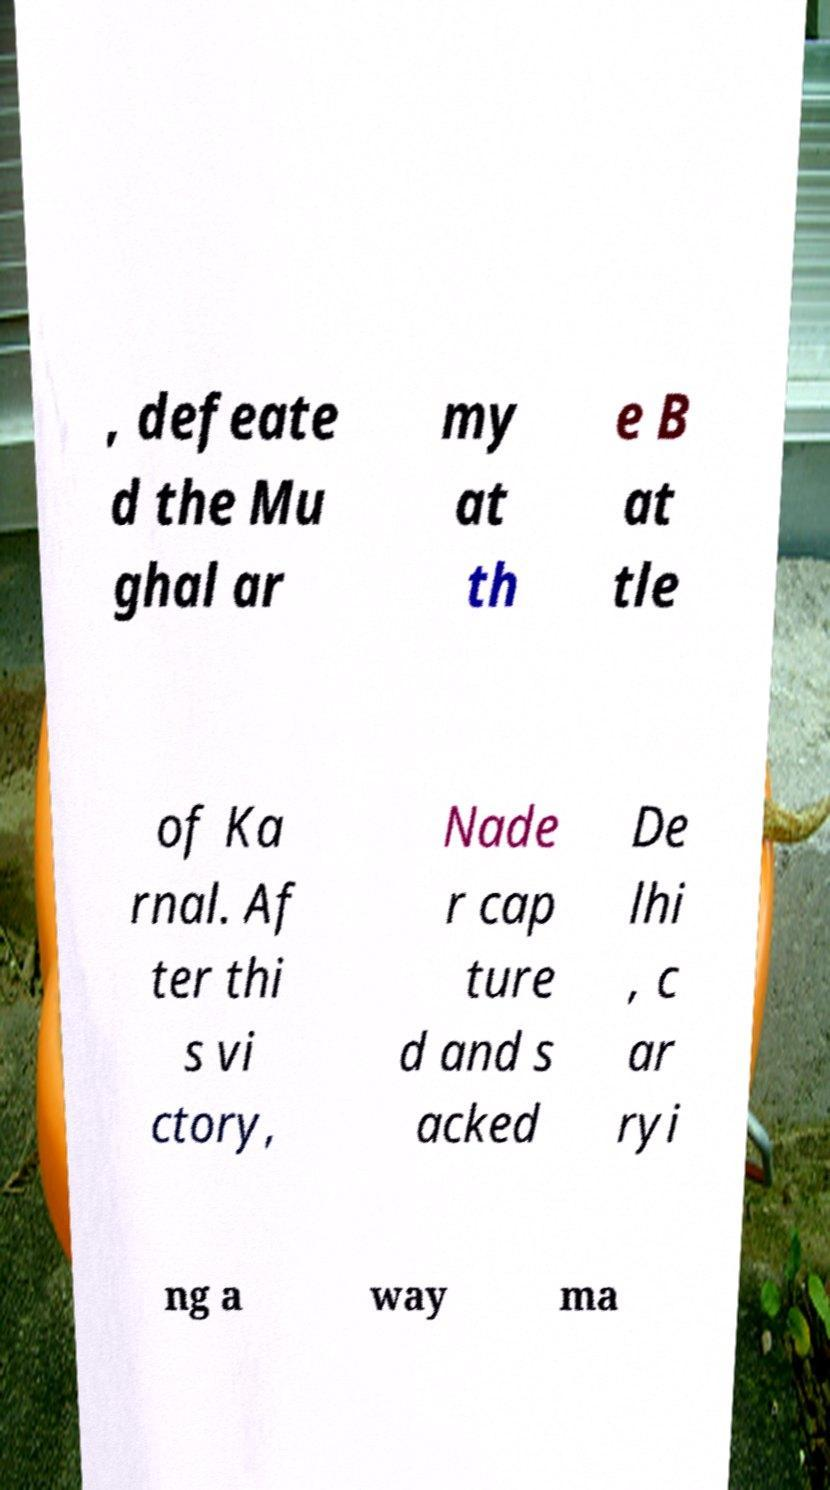I need the written content from this picture converted into text. Can you do that? , defeate d the Mu ghal ar my at th e B at tle of Ka rnal. Af ter thi s vi ctory, Nade r cap ture d and s acked De lhi , c ar ryi ng a way ma 